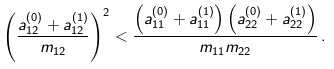Convert formula to latex. <formula><loc_0><loc_0><loc_500><loc_500>\left ( \frac { a ^ { ( 0 ) } _ { 1 2 } + a ^ { ( 1 ) } _ { 1 2 } } { m _ { 1 2 } } \right ) ^ { 2 } < \frac { \left ( a ^ { ( 0 ) } _ { 1 1 } + a ^ { ( 1 ) } _ { 1 1 } \right ) \left ( a ^ { ( 0 ) } _ { 2 2 } + a ^ { ( 1 ) } _ { 2 2 } \right ) } { m _ { 1 1 } m _ { 2 2 } } \, .</formula> 